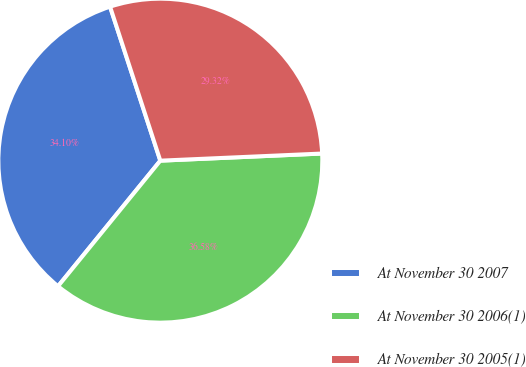<chart> <loc_0><loc_0><loc_500><loc_500><pie_chart><fcel>At November 30 2007<fcel>At November 30 2006(1)<fcel>At November 30 2005(1)<nl><fcel>34.1%<fcel>36.58%<fcel>29.32%<nl></chart> 